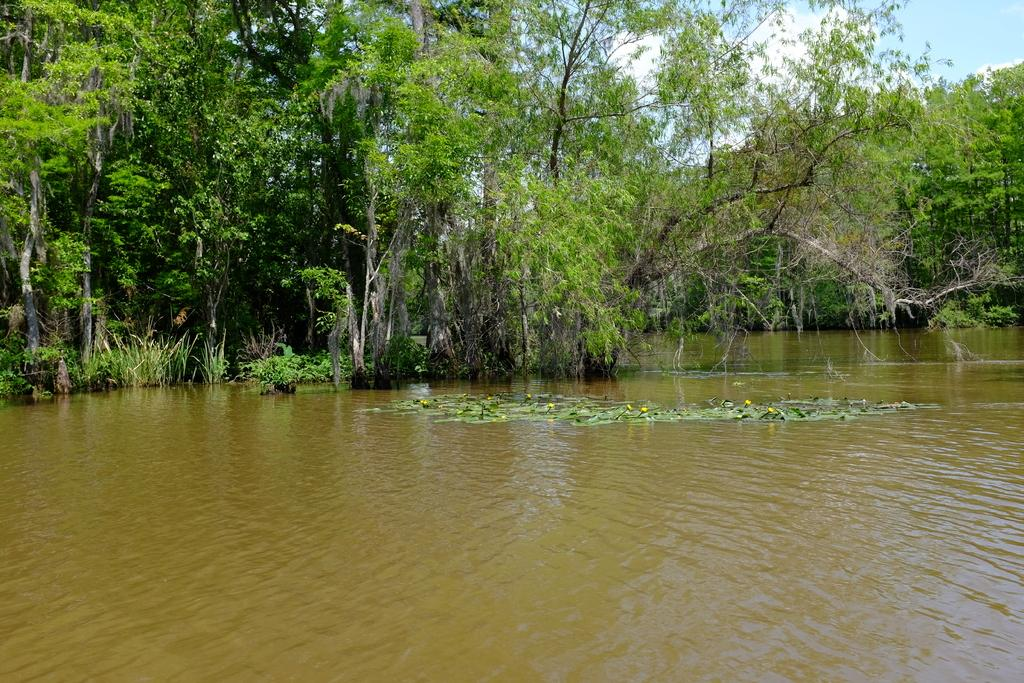What is in the water in the image? There are flowers and leaves in the water in the image. What can be seen in the background of the image? There are plants and trees in the background of the image. What is visible in the sky in the image? The sky is visible in the background of the image. How many apples can be seen running through the image? There are no apples present in the image. 